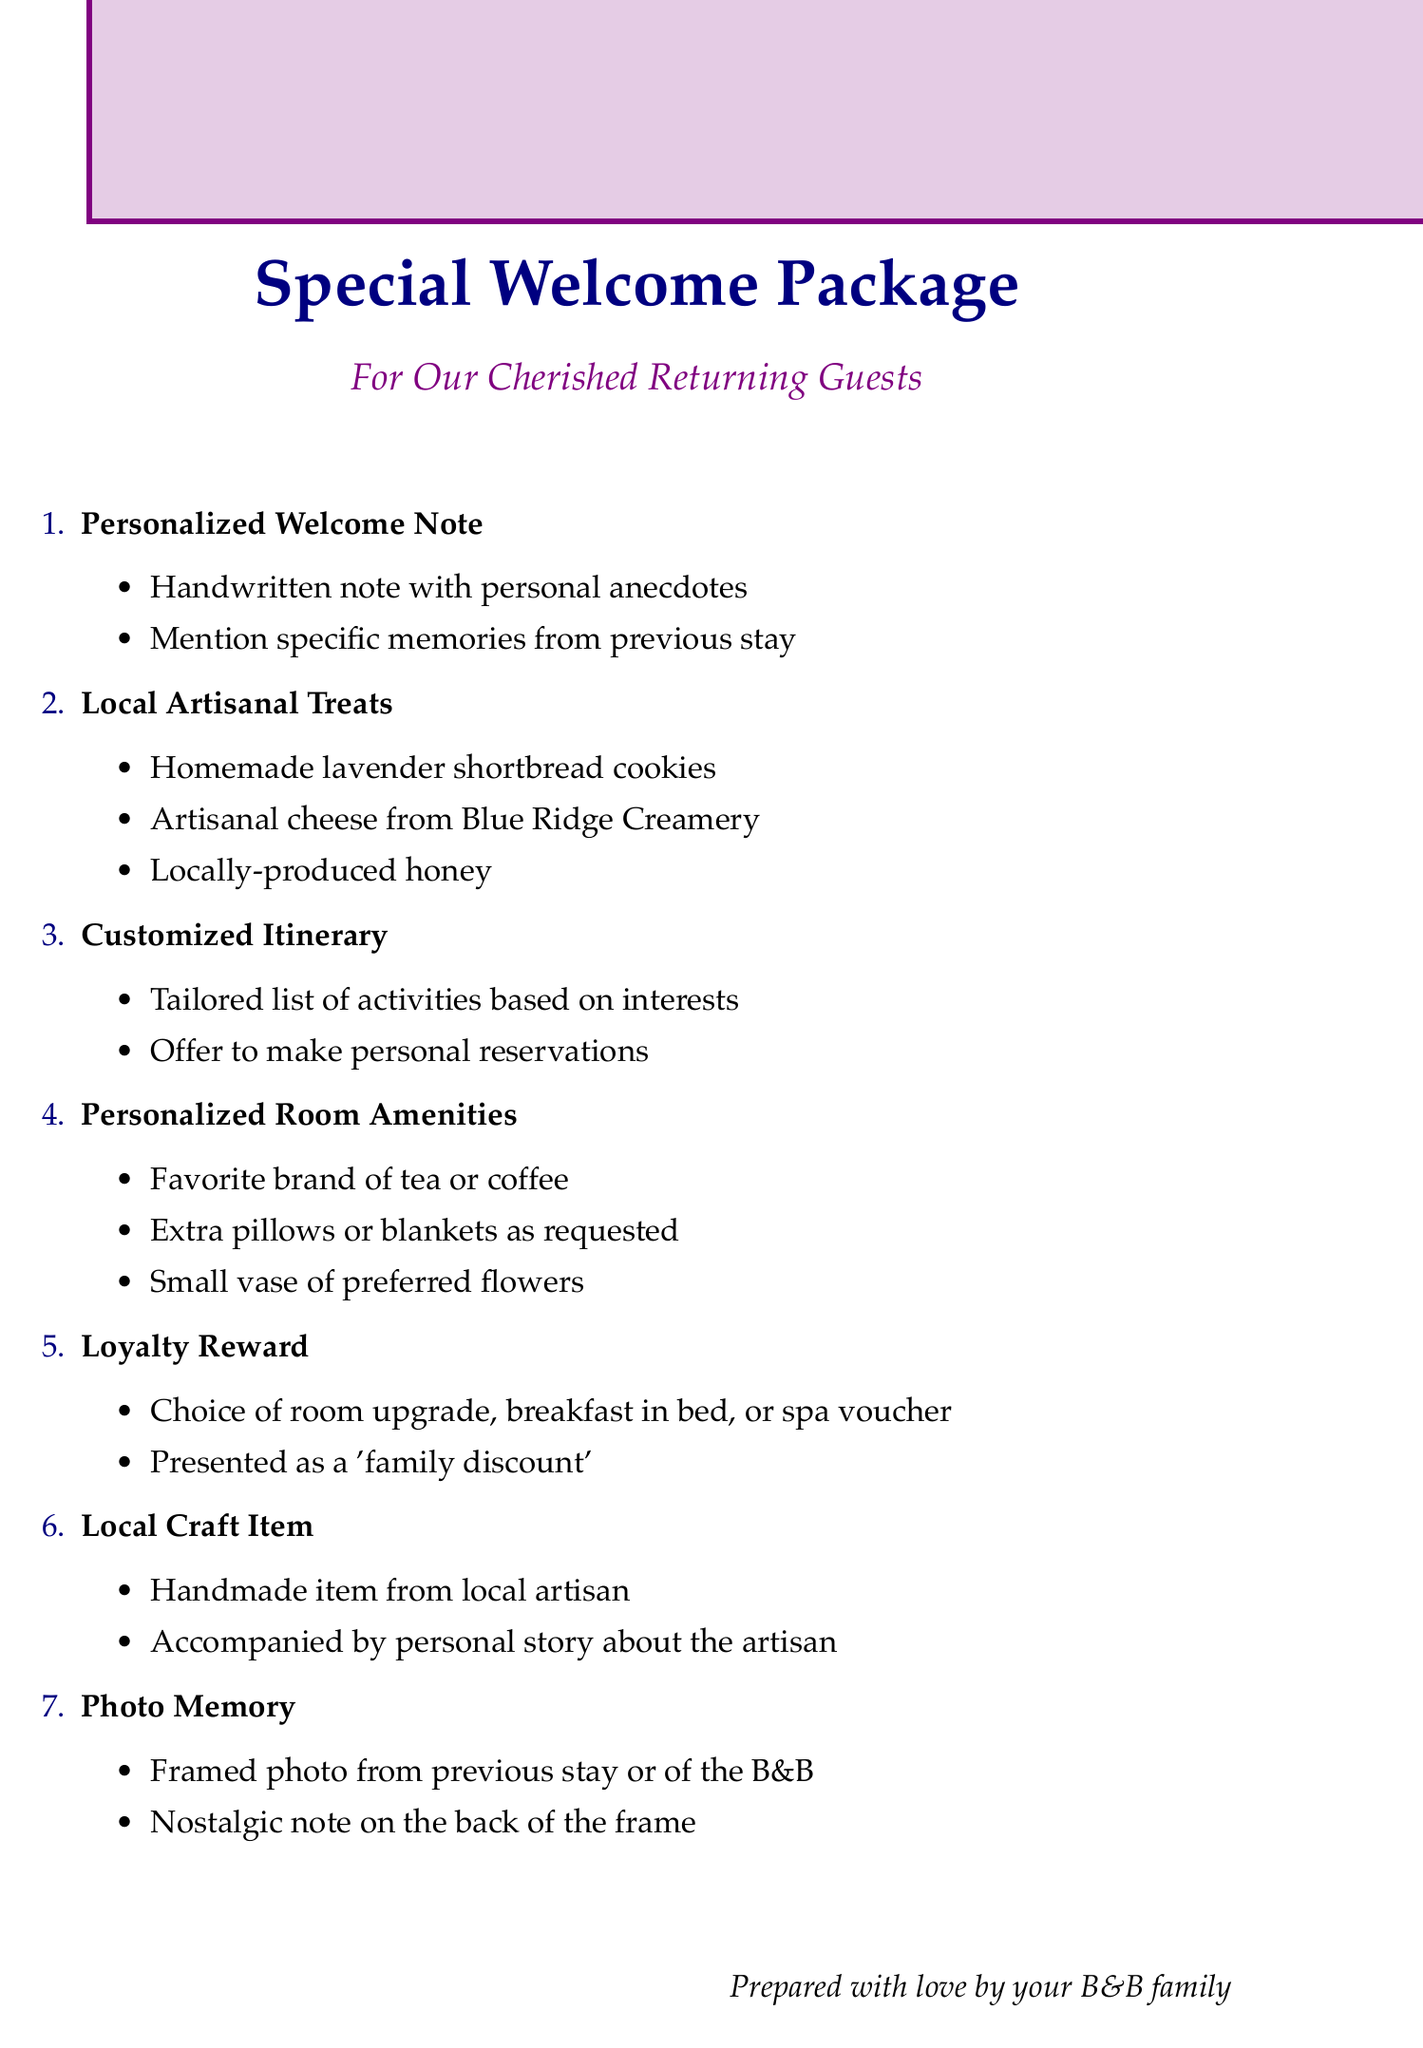What is included in the personalized welcome note? The personalized welcome note includes a handwritten note expressing gratitude for their return visit and mentioning specific memories from their previous stay.
Answer: Handwritten note expressing gratitude and memories What types of local artisanal treats are offered? The document lists specific items included in the local artisanal treats, which comprise homemade lavender shortbread cookies, artisanal cheese, and locally-produced honey.
Answer: Homemade lavender shortbread cookies, artisanal cheese, locally-produced honey What is one item that would be included in the customized itinerary? The document provides examples of activities tailored to the guest's interests, including wine tasting, guided hiking, and attending shows, one of which can be selected for the itinerary.
Answer: Wine tasting at Oakridge Vineyards What special perk do repeat guests receive? The loyalty reward offers special perks or discounts to repeat guests, like free breakfast or room upgrades, established to acknowledge their status.
Answer: Special perk or discount for repeat guests How are personalized room amenities selected? The selection for personalized room amenities is based on known preferences indicated in previous stays of the guests, reflecting an attentive approach to their needs.
Answer: Based on known preferences from previous stays What is the goal of preparing a photo memory? The framed photo is meant to evoke nostalgia by capturing a moment from the previous stay, allowing the guests to reminisce about their time spent at the B&B.
Answer: Evoke nostalgia from previous stay What is a potential local craft item mentioned? The document provides options for local craft items, including handmade items from artisans, which are chosen to reflect the uniqueness of local craftsmanship.
Answer: Hand-knitted scarf from Cozy Knits Who is responsible for arranging special services? The document mentions that the housekeeper should use their insider knowledge to arrange and book the necessary special services for guests.
Answer: The housekeeper 